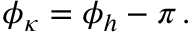<formula> <loc_0><loc_0><loc_500><loc_500>\phi _ { \kappa } = \phi _ { h } - \pi \, .</formula> 